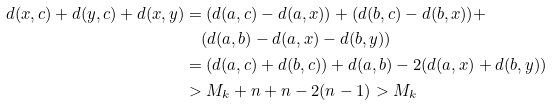<formula> <loc_0><loc_0><loc_500><loc_500>d ( x , c ) + d ( y , c ) + d ( x , y ) & = ( d ( a , c ) - d ( a , x ) ) + ( d ( b , c ) - d ( b , x ) ) + \\ & \quad ( d ( a , b ) - d ( a , x ) - d ( b , y ) ) \\ & = ( d ( a , c ) + d ( b , c ) ) + d ( a , b ) - 2 ( d ( a , x ) + d ( b , y ) ) \\ & > M _ { k } + n + n - 2 ( n - 1 ) > M _ { k }</formula> 